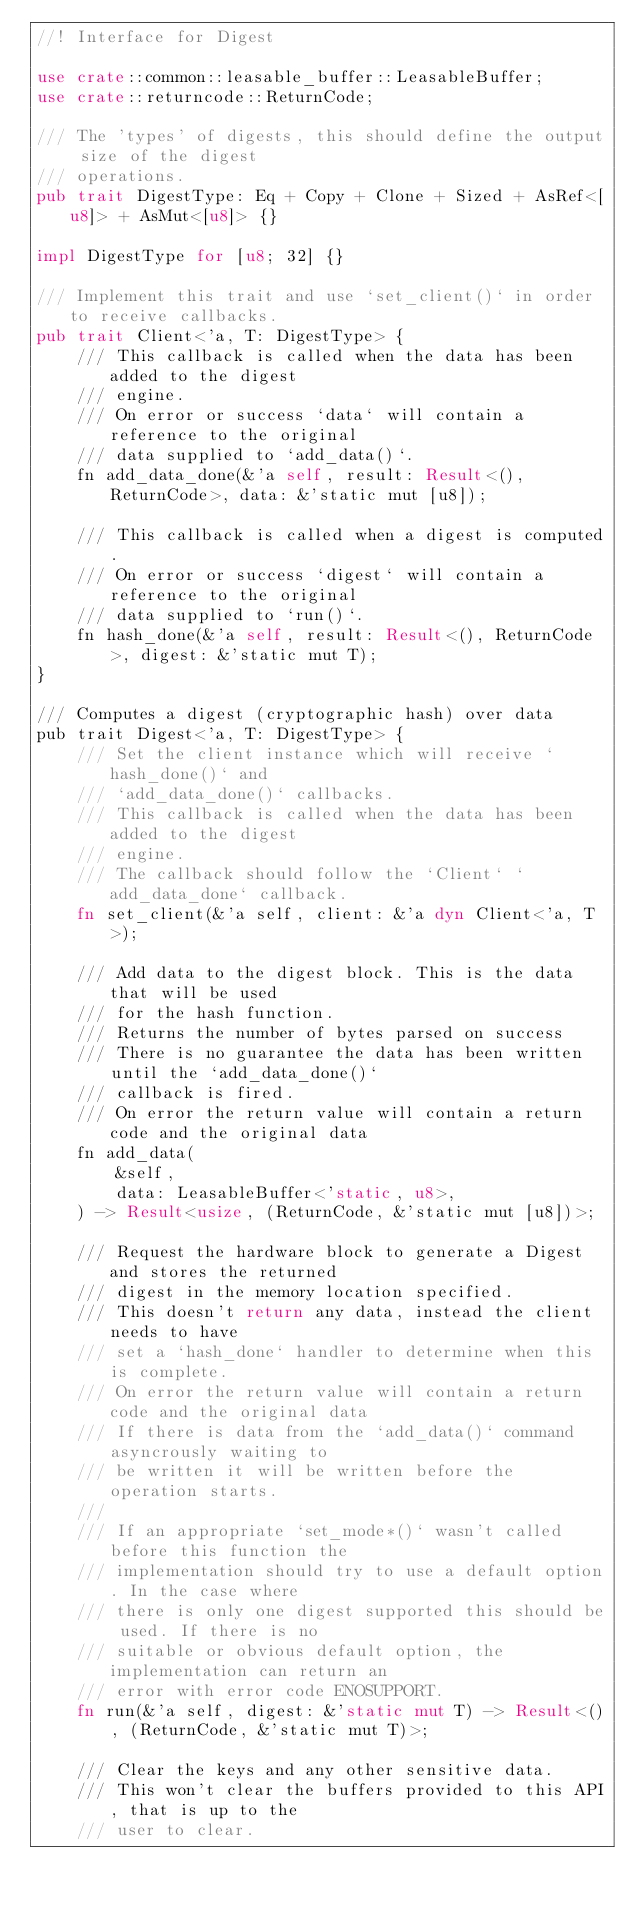<code> <loc_0><loc_0><loc_500><loc_500><_Rust_>//! Interface for Digest

use crate::common::leasable_buffer::LeasableBuffer;
use crate::returncode::ReturnCode;

/// The 'types' of digests, this should define the output size of the digest
/// operations.
pub trait DigestType: Eq + Copy + Clone + Sized + AsRef<[u8]> + AsMut<[u8]> {}

impl DigestType for [u8; 32] {}

/// Implement this trait and use `set_client()` in order to receive callbacks.
pub trait Client<'a, T: DigestType> {
    /// This callback is called when the data has been added to the digest
    /// engine.
    /// On error or success `data` will contain a reference to the original
    /// data supplied to `add_data()`.
    fn add_data_done(&'a self, result: Result<(), ReturnCode>, data: &'static mut [u8]);

    /// This callback is called when a digest is computed.
    /// On error or success `digest` will contain a reference to the original
    /// data supplied to `run()`.
    fn hash_done(&'a self, result: Result<(), ReturnCode>, digest: &'static mut T);
}

/// Computes a digest (cryptographic hash) over data
pub trait Digest<'a, T: DigestType> {
    /// Set the client instance which will receive `hash_done()` and
    /// `add_data_done()` callbacks.
    /// This callback is called when the data has been added to the digest
    /// engine.
    /// The callback should follow the `Client` `add_data_done` callback.
    fn set_client(&'a self, client: &'a dyn Client<'a, T>);

    /// Add data to the digest block. This is the data that will be used
    /// for the hash function.
    /// Returns the number of bytes parsed on success
    /// There is no guarantee the data has been written until the `add_data_done()`
    /// callback is fired.
    /// On error the return value will contain a return code and the original data
    fn add_data(
        &self,
        data: LeasableBuffer<'static, u8>,
    ) -> Result<usize, (ReturnCode, &'static mut [u8])>;

    /// Request the hardware block to generate a Digest and stores the returned
    /// digest in the memory location specified.
    /// This doesn't return any data, instead the client needs to have
    /// set a `hash_done` handler to determine when this is complete.
    /// On error the return value will contain a return code and the original data
    /// If there is data from the `add_data()` command asyncrously waiting to
    /// be written it will be written before the operation starts.
    ///
    /// If an appropriate `set_mode*()` wasn't called before this function the
    /// implementation should try to use a default option. In the case where
    /// there is only one digest supported this should be used. If there is no
    /// suitable or obvious default option, the implementation can return an
    /// error with error code ENOSUPPORT.
    fn run(&'a self, digest: &'static mut T) -> Result<(), (ReturnCode, &'static mut T)>;

    /// Clear the keys and any other sensitive data.
    /// This won't clear the buffers provided to this API, that is up to the
    /// user to clear.</code> 